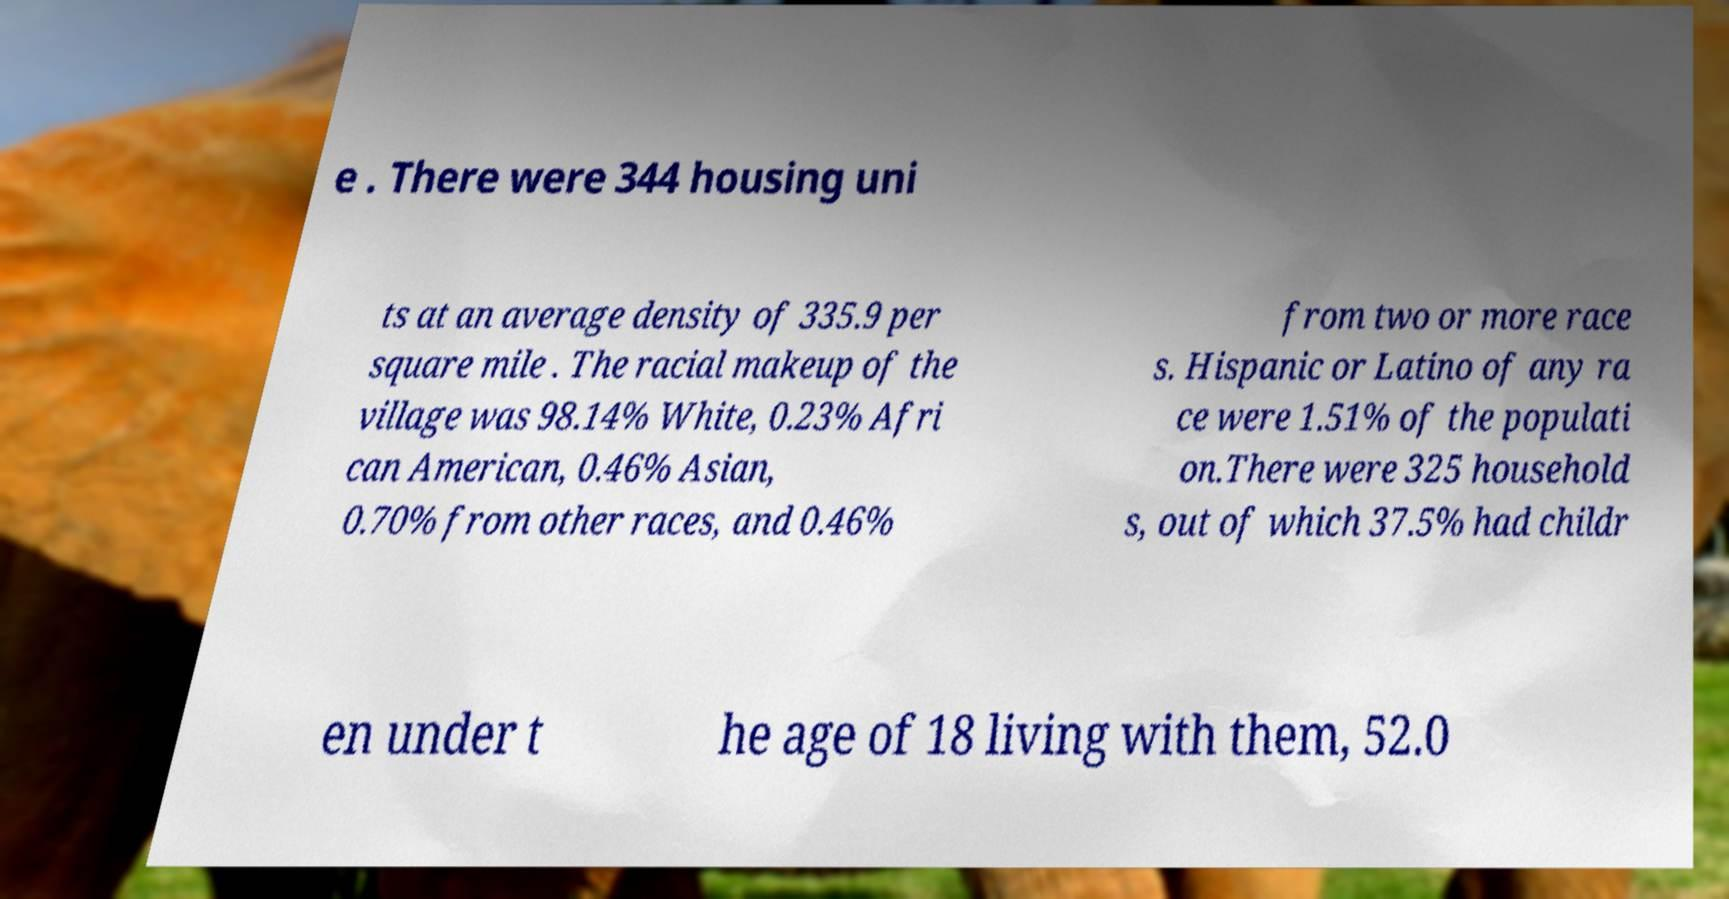There's text embedded in this image that I need extracted. Can you transcribe it verbatim? e . There were 344 housing uni ts at an average density of 335.9 per square mile . The racial makeup of the village was 98.14% White, 0.23% Afri can American, 0.46% Asian, 0.70% from other races, and 0.46% from two or more race s. Hispanic or Latino of any ra ce were 1.51% of the populati on.There were 325 household s, out of which 37.5% had childr en under t he age of 18 living with them, 52.0 